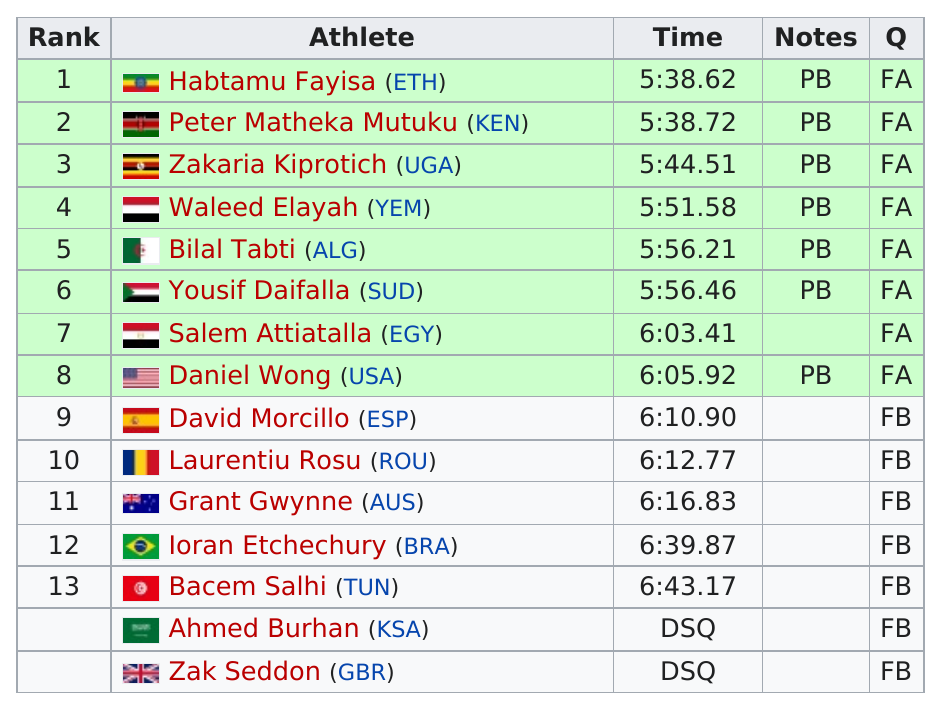Specify some key components in this picture. There are a total of racers who finished under 6:00.00 The athlete Laurentiu Rosu, belonging to the rank of 10, is from Romania. Bacem Salhi took the most time to complete the event. Peter Matheka Mutuku completed the event in a time of 5 hours and 38 minutes and 72 seconds. The ranking number for Grant Gwynne is 11. 